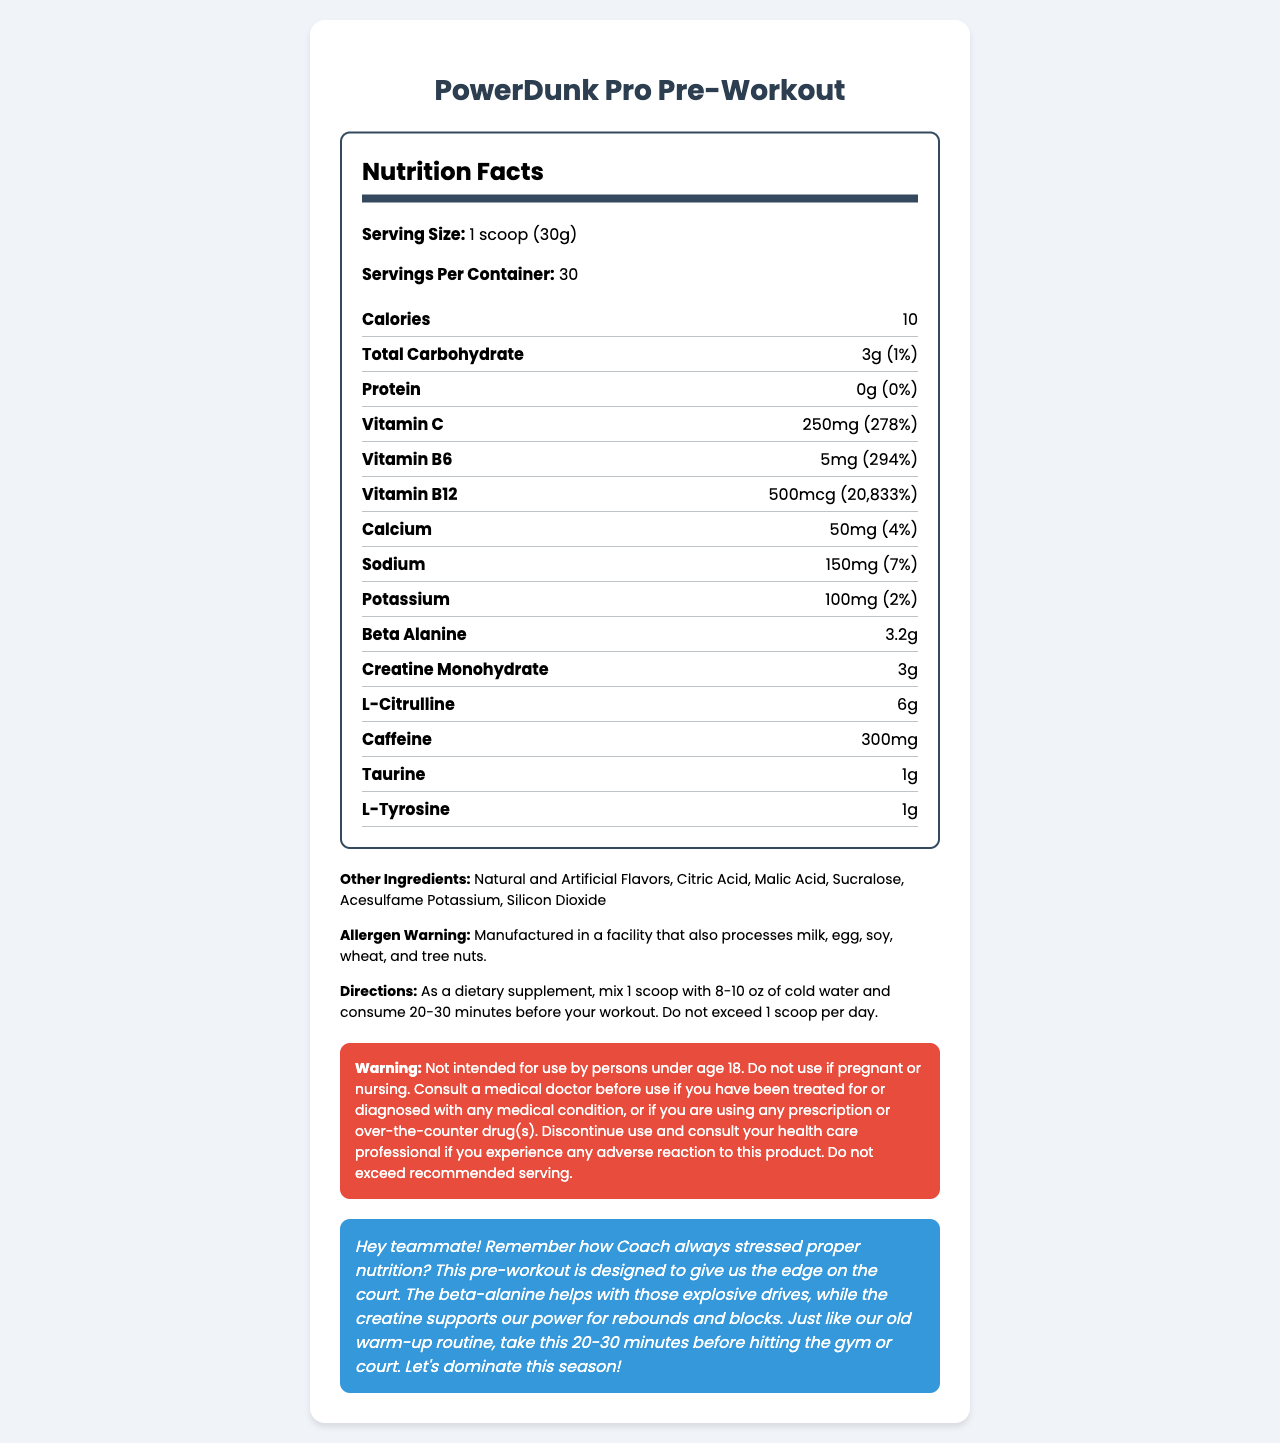what is the serving size for PowerDunk Pro Pre-Workout? The serving size is stated as "1 scoop (30g)" directly in the document.
Answer: 1 scoop (30g) how many servings are there in a container? The document states that there are "Servings Per Container: 30".
Answer: 30 how many calories does one serving contain? The calorie content per serving is given as "10".
Answer: 10 what is the daily value percentage of vitamin C in one serving? The document lists Vitamin C with an amount of "250mg" which equals to "278%" of the daily value.
Answer: 278% what is the daily value percentage of sodium in one serving? The sodium content is provided as "150mg" which is "7%" of the daily value.
Answer: 7% which ingredient amount is the highest in one serving? A. Beta Alanine B. Vitamin B12 C. Sodium D. L-Citrulline L-Citrulline is listed as "6g", which is the highest amount listed for any ingredient.
Answer: D what is the primary function of beta alanine in this product according to the basketball-specific note? A. Helps with explosive drives B. Improves stamina C. Reduces muscle cramps D. Increases focus The note specifies that beta alanine helps with "explosive drives."
Answer: A does this product contain protein? The document indicates "Protein: 0g (0%)".
Answer: No is it safe for someone under 18 to use this product? The warning specifically states "Not intended for use by persons under age 18."
Answer: No summarize the main purpose and key features of the PowerDunk Pro Pre-Workout supplement. The document describes PowerDunk Pro Pre-Workout as a specialized supplement intended to boost athletic performance with ingredients geared towards enhancing endurance, power, and overall workout effectiveness. Key ingredients include beta alanine for explosive movements, creatine for power, and caffeine for energy. Specific usage instructions and safety warnings are included.
Answer: The PowerDunk Pro Pre-Workout supplement is designed to enhance athletic performance, particularly for basketball players. It contains various vitamins, minerals, and performance-enhancing ingredients like beta alanine, creatine monohydrate, and caffeine. The supplement helps with energy levels, power for rebounds and blocks, and explosive drives. It's recommended to use one scoop mixed with water 20-30 minutes before a workout. is the exact percentage daily value for beta alanine provided in the document? The document uses "†" next to beta alanine, indicating that the daily value percentage is not provided.
Answer: No what is the potential allergen warning for this product? The allergen warning is explicitly stated, indicating potential cross-contamination with common allergens.
Answer: Manufactured in a facility that also processes milk, egg, soy, wheat, and tree nuts. who cannot use this product according to the warning section? The warning explicitly states groups that should avoid using the product.
​
Answer: Persons under age 18, pregnant or nursing women, and those with medical conditions without doctor's consultation. 